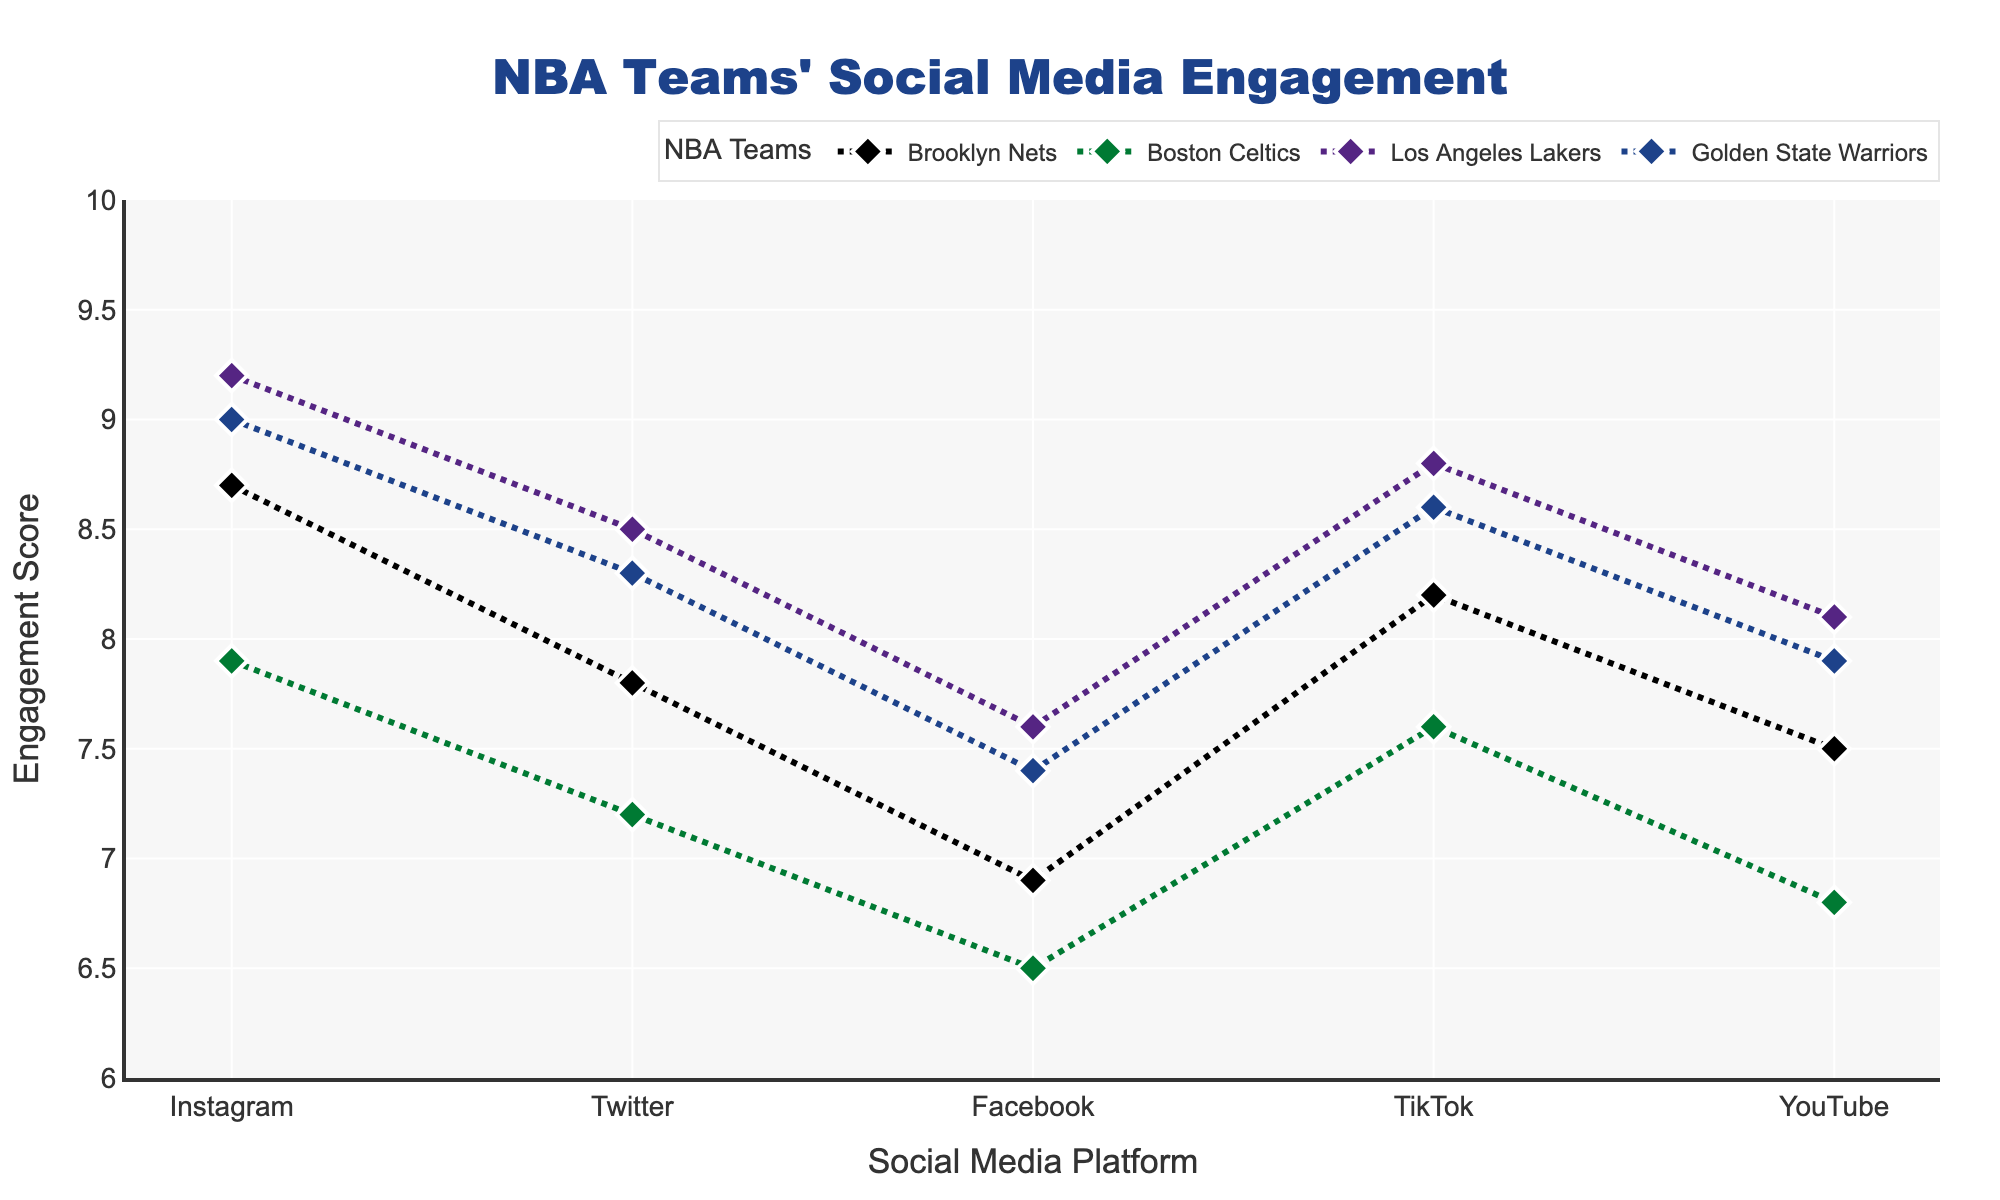What is the title of the figure? The title can be found at the top of the figure. It reads "NBA Teams' Social Media Engagement"
Answer: NBA Teams' Social Media Engagement Which team has the highest engagement score on Instagram? By looking at the engagement scores for each team on Instagram, the highest score is for the Los Angeles Lakers with a score of 9.2
Answer: Los Angeles Lakers How does Brooklyn Nets' engagement on Twitter compare to that on Instagram? The Brooklyn Nets' engagement score on Twitter is 7.8, while on Instagram it is 8.7. Comparing these, the score on Instagram is higher than on Twitter
Answer: Instagram score is higher What is the difference between the engagement scores of the Brooklyn Nets on TikTok and Facebook? The engagement score for the Brooklyn Nets on TikTok is 8.2, and on Facebook, it is 6.9. The difference is calculated by 8.2 - 6.9 = 1.3
Answer: 1.3 Which platform has the lowest engagement score for the Brooklyn Nets? By looking at the engagement scores for the Brooklyn Nets across all platforms, the lowest score is on Facebook with a score of 6.9
Answer: Facebook What is the average engagement score for the Brooklyn Nets across all platforms? The scores for the Brooklyn Nets are: Instagram (8.7), Twitter (7.8), Facebook (6.9), TikTok (8.2), and YouTube (7.5). The average is calculated by summing these: (8.7 + 7.8 + 6.9 + 8.2 + 7.5) / 5 = 7.82
Answer: 7.82 Which team has a higher engagement score on YouTube, Brooklyn Nets or Golden State Warriors? The engagement score for Brooklyn Nets on YouTube is 7.5, and for Golden State Warriors, it is 7.9. Thus, the Golden State Warriors have a higher score on YouTube
Answer: Golden State Warriors Does any team have an engagement score of exactly 7 on any platform? By examining the data points, no team has an engagement score of exactly 7 on any platform
Answer: No What is the median engagement score for Brooklyn Nets across all platforms? The engagement scores for Brooklyn Nets are: 8.7 (Instagram), 7.8 (Twitter), 6.9 (Facebook), 8.2 (TikTok), and 7.5 (YouTube). Ordered, they are 6.9, 7.5, 7.8, 8.2, 8.7. The median value is 7.8 (third value)
Answer: 7.8 How many data points are represented in the figure? There are 4 teams and each team has data across 5 platforms, making a total of 4 * 5 = 20 data points
Answer: 20 